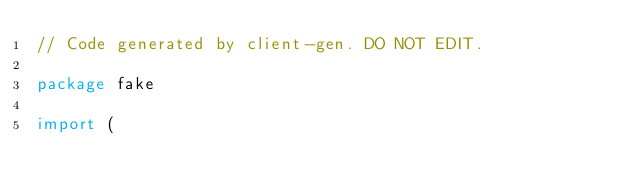Convert code to text. <code><loc_0><loc_0><loc_500><loc_500><_Go_>// Code generated by client-gen. DO NOT EDIT.

package fake

import (</code> 